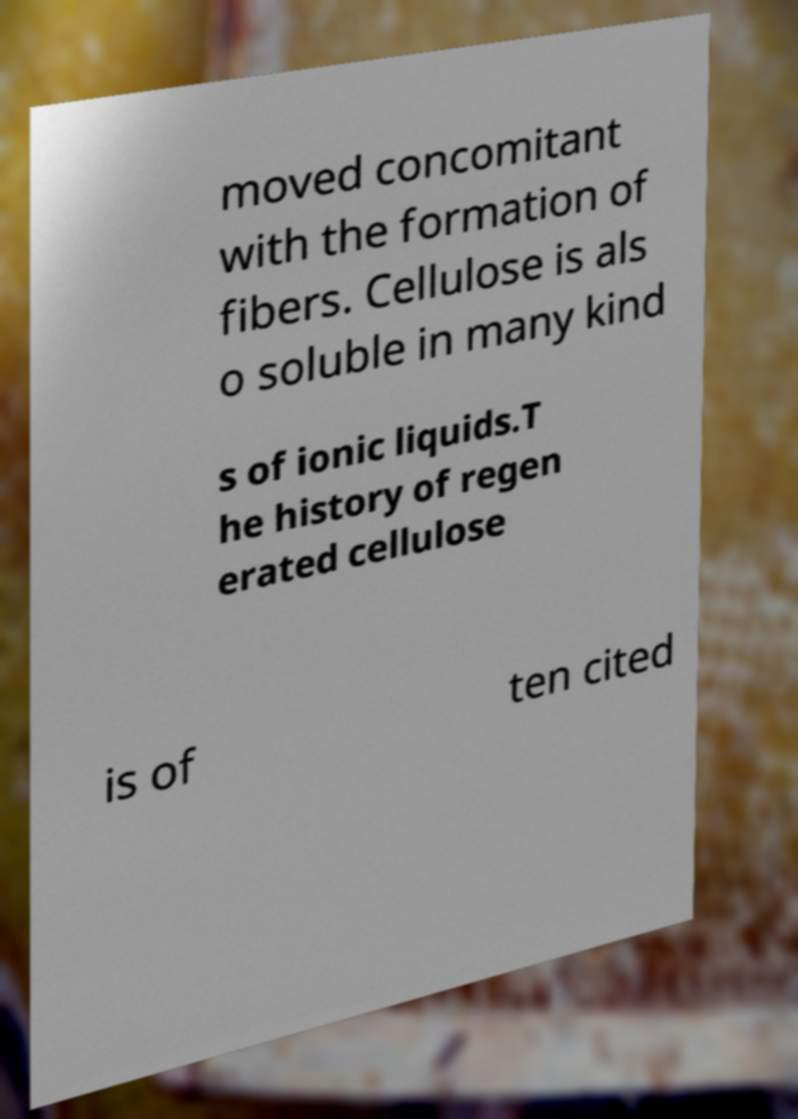Could you assist in decoding the text presented in this image and type it out clearly? moved concomitant with the formation of fibers. Cellulose is als o soluble in many kind s of ionic liquids.T he history of regen erated cellulose is of ten cited 